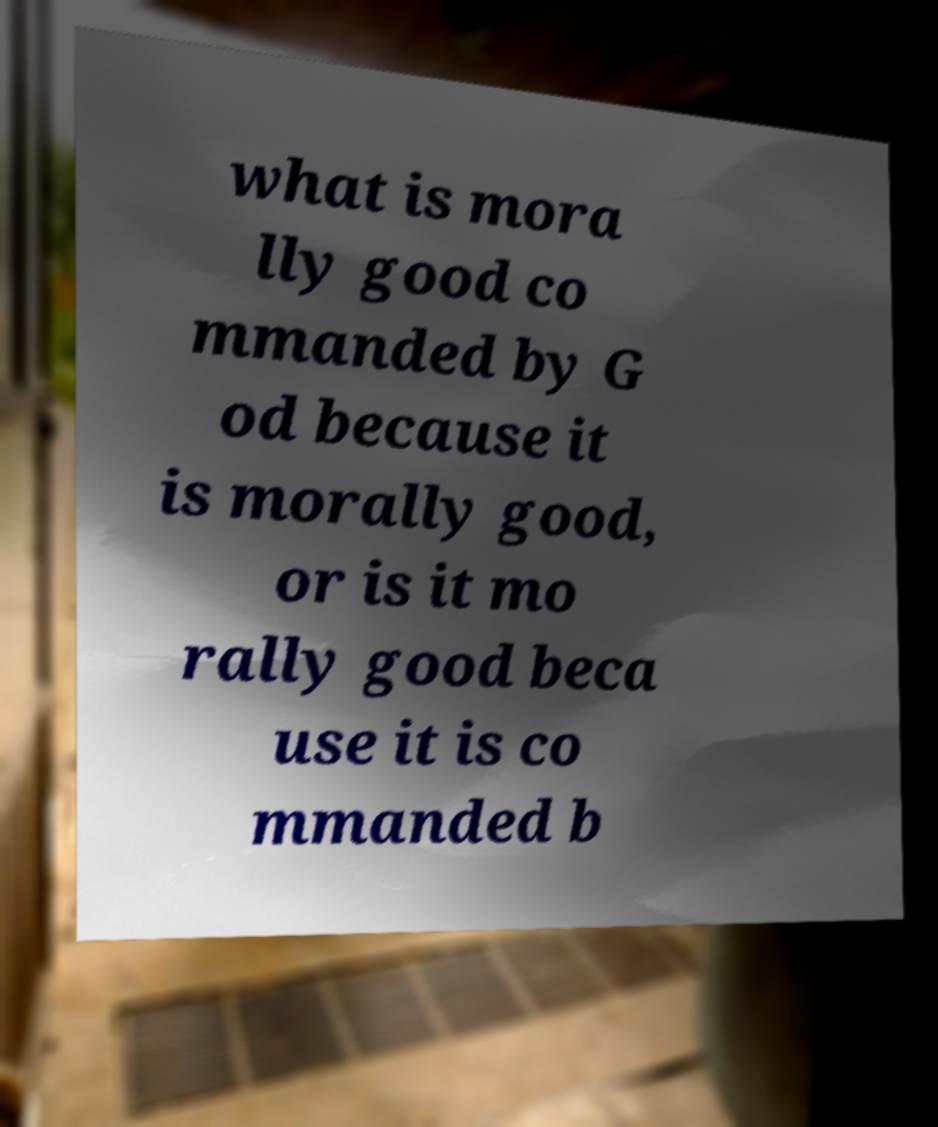Could you extract and type out the text from this image? what is mora lly good co mmanded by G od because it is morally good, or is it mo rally good beca use it is co mmanded b 